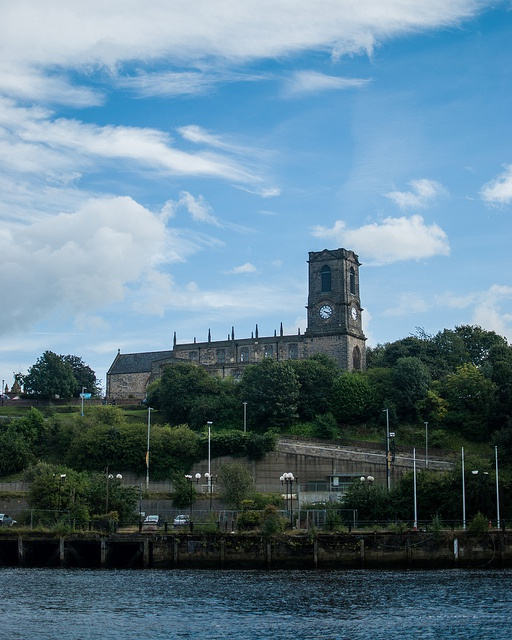Describe the objects in this image and their specific colors. I can see car in lightgray, black, teal, gray, and darkblue tones, car in lightgray, black, gray, and blue tones, clock in lightgray, gray, lightblue, and blue tones, car in lightgray, black, gray, and darkgray tones, and clock in lightgray, gray, and darkgray tones in this image. 